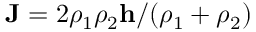<formula> <loc_0><loc_0><loc_500><loc_500>J = 2 \rho _ { 1 } \rho _ { 2 } h / ( \rho _ { 1 } + \rho _ { 2 } )</formula> 